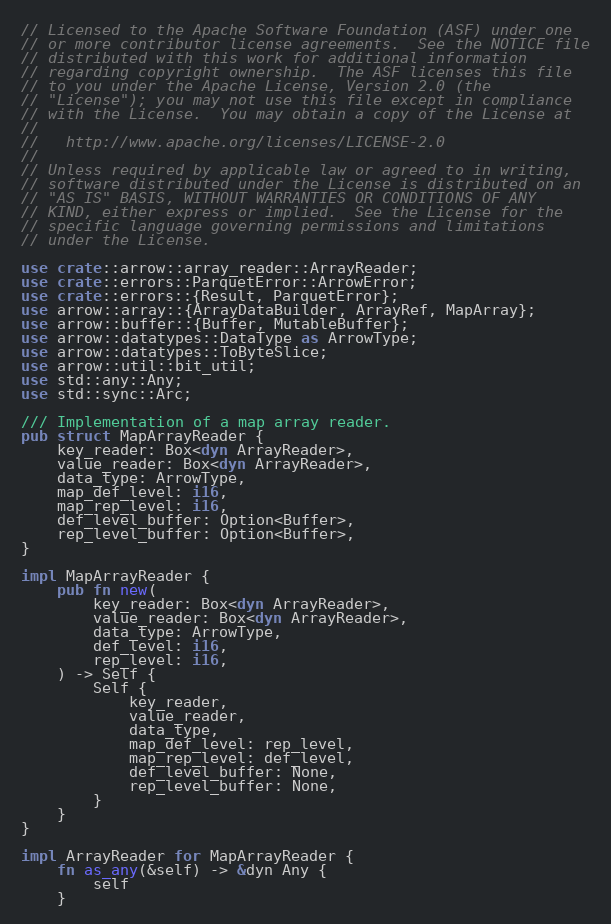Convert code to text. <code><loc_0><loc_0><loc_500><loc_500><_Rust_>// Licensed to the Apache Software Foundation (ASF) under one
// or more contributor license agreements.  See the NOTICE file
// distributed with this work for additional information
// regarding copyright ownership.  The ASF licenses this file
// to you under the Apache License, Version 2.0 (the
// "License"); you may not use this file except in compliance
// with the License.  You may obtain a copy of the License at
//
//   http://www.apache.org/licenses/LICENSE-2.0
//
// Unless required by applicable law or agreed to in writing,
// software distributed under the License is distributed on an
// "AS IS" BASIS, WITHOUT WARRANTIES OR CONDITIONS OF ANY
// KIND, either express or implied.  See the License for the
// specific language governing permissions and limitations
// under the License.

use crate::arrow::array_reader::ArrayReader;
use crate::errors::ParquetError::ArrowError;
use crate::errors::{Result, ParquetError};
use arrow::array::{ArrayDataBuilder, ArrayRef, MapArray};
use arrow::buffer::{Buffer, MutableBuffer};
use arrow::datatypes::DataType as ArrowType;
use arrow::datatypes::ToByteSlice;
use arrow::util::bit_util;
use std::any::Any;
use std::sync::Arc;

/// Implementation of a map array reader.
pub struct MapArrayReader {
    key_reader: Box<dyn ArrayReader>,
    value_reader: Box<dyn ArrayReader>,
    data_type: ArrowType,
    map_def_level: i16,
    map_rep_level: i16,
    def_level_buffer: Option<Buffer>,
    rep_level_buffer: Option<Buffer>,
}

impl MapArrayReader {
    pub fn new(
        key_reader: Box<dyn ArrayReader>,
        value_reader: Box<dyn ArrayReader>,
        data_type: ArrowType,
        def_level: i16,
        rep_level: i16,
    ) -> Self {
        Self {
            key_reader,
            value_reader,
            data_type,
            map_def_level: rep_level,
            map_rep_level: def_level,
            def_level_buffer: None,
            rep_level_buffer: None,
        }
    }
}

impl ArrayReader for MapArrayReader {
    fn as_any(&self) -> &dyn Any {
        self
    }
</code> 